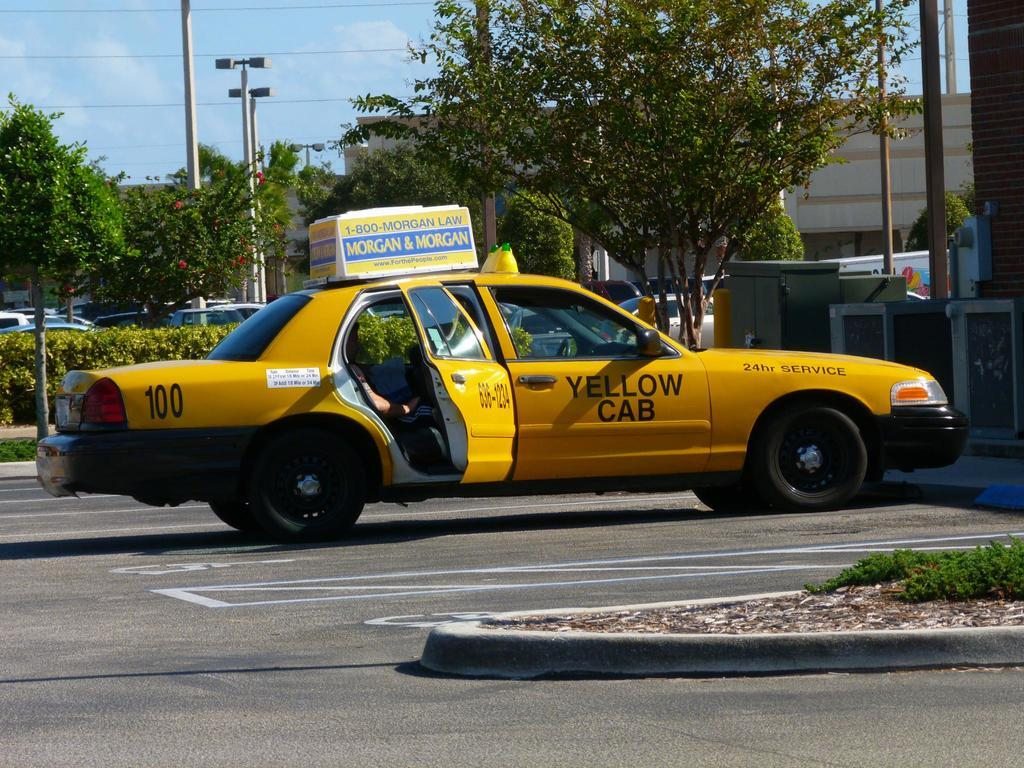<image>
Write a terse but informative summary of the picture. A taxi cab has a Morgan & Morgan advertisement on top of it. 